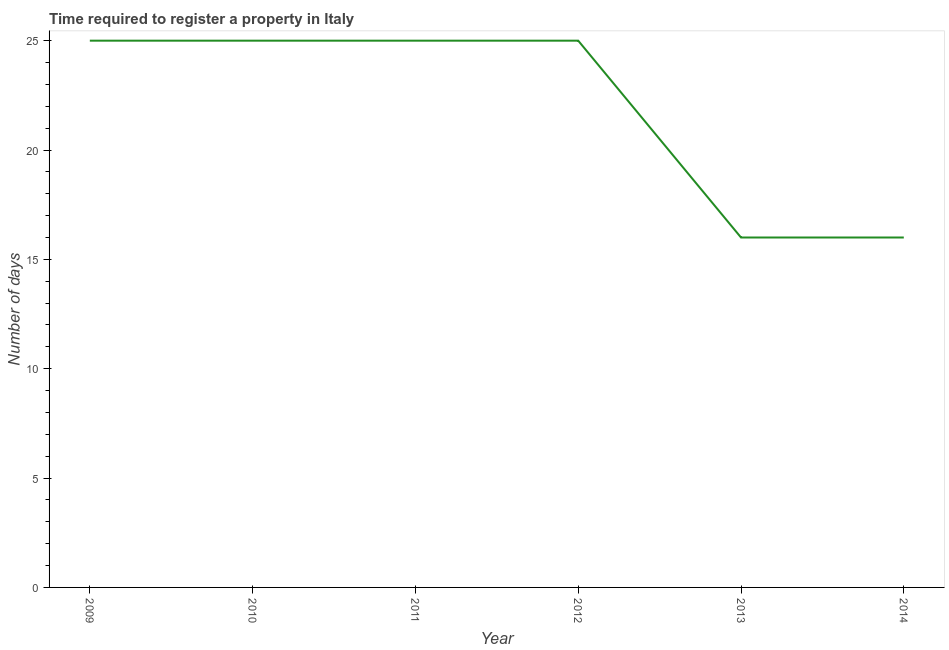What is the number of days required to register property in 2009?
Your response must be concise. 25. Across all years, what is the maximum number of days required to register property?
Your answer should be very brief. 25. Across all years, what is the minimum number of days required to register property?
Provide a succinct answer. 16. In which year was the number of days required to register property maximum?
Keep it short and to the point. 2009. In which year was the number of days required to register property minimum?
Ensure brevity in your answer.  2013. What is the sum of the number of days required to register property?
Offer a terse response. 132. What is the difference between the number of days required to register property in 2011 and 2014?
Keep it short and to the point. 9. What is the average number of days required to register property per year?
Ensure brevity in your answer.  22. In how many years, is the number of days required to register property greater than 15 days?
Your response must be concise. 6. What is the ratio of the number of days required to register property in 2011 to that in 2013?
Make the answer very short. 1.56. Is the number of days required to register property in 2010 less than that in 2012?
Make the answer very short. No. Is the difference between the number of days required to register property in 2010 and 2011 greater than the difference between any two years?
Provide a succinct answer. No. What is the difference between the highest and the second highest number of days required to register property?
Your answer should be compact. 0. Is the sum of the number of days required to register property in 2011 and 2012 greater than the maximum number of days required to register property across all years?
Your answer should be very brief. Yes. What is the difference between the highest and the lowest number of days required to register property?
Your answer should be compact. 9. Does the number of days required to register property monotonically increase over the years?
Provide a succinct answer. No. How many lines are there?
Offer a terse response. 1. How many years are there in the graph?
Offer a very short reply. 6. Are the values on the major ticks of Y-axis written in scientific E-notation?
Ensure brevity in your answer.  No. What is the title of the graph?
Provide a short and direct response. Time required to register a property in Italy. What is the label or title of the Y-axis?
Your response must be concise. Number of days. What is the Number of days of 2012?
Give a very brief answer. 25. What is the Number of days of 2013?
Provide a short and direct response. 16. What is the Number of days in 2014?
Your response must be concise. 16. What is the difference between the Number of days in 2009 and 2010?
Provide a short and direct response. 0. What is the difference between the Number of days in 2009 and 2012?
Offer a terse response. 0. What is the difference between the Number of days in 2009 and 2013?
Keep it short and to the point. 9. What is the difference between the Number of days in 2009 and 2014?
Make the answer very short. 9. What is the difference between the Number of days in 2010 and 2012?
Provide a succinct answer. 0. What is the difference between the Number of days in 2010 and 2013?
Keep it short and to the point. 9. What is the difference between the Number of days in 2011 and 2014?
Provide a succinct answer. 9. What is the difference between the Number of days in 2012 and 2014?
Provide a short and direct response. 9. What is the ratio of the Number of days in 2009 to that in 2013?
Offer a very short reply. 1.56. What is the ratio of the Number of days in 2009 to that in 2014?
Your response must be concise. 1.56. What is the ratio of the Number of days in 2010 to that in 2011?
Offer a terse response. 1. What is the ratio of the Number of days in 2010 to that in 2012?
Provide a short and direct response. 1. What is the ratio of the Number of days in 2010 to that in 2013?
Give a very brief answer. 1.56. What is the ratio of the Number of days in 2010 to that in 2014?
Offer a terse response. 1.56. What is the ratio of the Number of days in 2011 to that in 2012?
Your response must be concise. 1. What is the ratio of the Number of days in 2011 to that in 2013?
Your response must be concise. 1.56. What is the ratio of the Number of days in 2011 to that in 2014?
Offer a very short reply. 1.56. What is the ratio of the Number of days in 2012 to that in 2013?
Provide a succinct answer. 1.56. What is the ratio of the Number of days in 2012 to that in 2014?
Your answer should be compact. 1.56. 